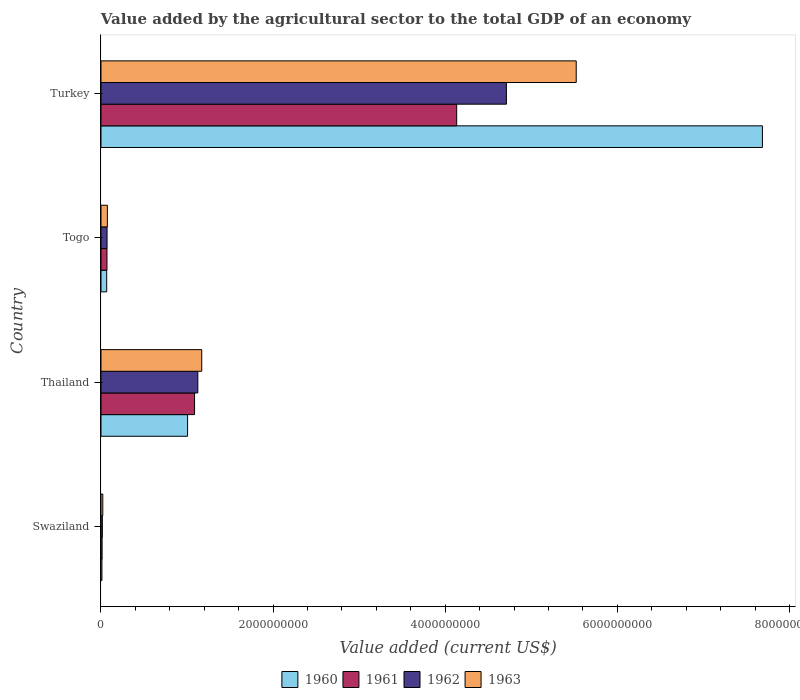How many groups of bars are there?
Ensure brevity in your answer.  4. Are the number of bars on each tick of the Y-axis equal?
Offer a terse response. Yes. How many bars are there on the 1st tick from the bottom?
Provide a succinct answer. 4. What is the label of the 2nd group of bars from the top?
Make the answer very short. Togo. In how many cases, is the number of bars for a given country not equal to the number of legend labels?
Provide a succinct answer. 0. What is the value added by the agricultural sector to the total GDP in 1960 in Turkey?
Your response must be concise. 7.69e+09. Across all countries, what is the maximum value added by the agricultural sector to the total GDP in 1961?
Offer a very short reply. 4.13e+09. Across all countries, what is the minimum value added by the agricultural sector to the total GDP in 1961?
Provide a succinct answer. 1.30e+07. In which country was the value added by the agricultural sector to the total GDP in 1961 maximum?
Your answer should be compact. Turkey. In which country was the value added by the agricultural sector to the total GDP in 1963 minimum?
Ensure brevity in your answer.  Swaziland. What is the total value added by the agricultural sector to the total GDP in 1962 in the graph?
Give a very brief answer. 5.92e+09. What is the difference between the value added by the agricultural sector to the total GDP in 1960 in Thailand and that in Turkey?
Your response must be concise. -6.68e+09. What is the difference between the value added by the agricultural sector to the total GDP in 1961 in Turkey and the value added by the agricultural sector to the total GDP in 1960 in Thailand?
Ensure brevity in your answer.  3.13e+09. What is the average value added by the agricultural sector to the total GDP in 1961 per country?
Offer a very short reply. 1.33e+09. What is the difference between the value added by the agricultural sector to the total GDP in 1962 and value added by the agricultural sector to the total GDP in 1963 in Swaziland?
Provide a short and direct response. -5.04e+06. What is the ratio of the value added by the agricultural sector to the total GDP in 1960 in Swaziland to that in Togo?
Ensure brevity in your answer.  0.17. What is the difference between the highest and the second highest value added by the agricultural sector to the total GDP in 1962?
Your response must be concise. 3.59e+09. What is the difference between the highest and the lowest value added by the agricultural sector to the total GDP in 1963?
Your answer should be compact. 5.50e+09. In how many countries, is the value added by the agricultural sector to the total GDP in 1962 greater than the average value added by the agricultural sector to the total GDP in 1962 taken over all countries?
Ensure brevity in your answer.  1. Is the sum of the value added by the agricultural sector to the total GDP in 1960 in Thailand and Togo greater than the maximum value added by the agricultural sector to the total GDP in 1961 across all countries?
Offer a terse response. No. What does the 3rd bar from the top in Togo represents?
Make the answer very short. 1961. Are all the bars in the graph horizontal?
Give a very brief answer. Yes. What is the difference between two consecutive major ticks on the X-axis?
Give a very brief answer. 2.00e+09. How are the legend labels stacked?
Provide a succinct answer. Horizontal. What is the title of the graph?
Provide a succinct answer. Value added by the agricultural sector to the total GDP of an economy. Does "2004" appear as one of the legend labels in the graph?
Provide a short and direct response. No. What is the label or title of the X-axis?
Provide a short and direct response. Value added (current US$). What is the Value added (current US$) in 1960 in Swaziland?
Ensure brevity in your answer.  1.11e+07. What is the Value added (current US$) in 1961 in Swaziland?
Your response must be concise. 1.30e+07. What is the Value added (current US$) of 1962 in Swaziland?
Keep it short and to the point. 1.60e+07. What is the Value added (current US$) of 1963 in Swaziland?
Provide a succinct answer. 2.10e+07. What is the Value added (current US$) of 1960 in Thailand?
Offer a very short reply. 1.01e+09. What is the Value added (current US$) in 1961 in Thailand?
Offer a very short reply. 1.09e+09. What is the Value added (current US$) of 1962 in Thailand?
Keep it short and to the point. 1.13e+09. What is the Value added (current US$) of 1963 in Thailand?
Offer a terse response. 1.17e+09. What is the Value added (current US$) of 1960 in Togo?
Keep it short and to the point. 6.65e+07. What is the Value added (current US$) in 1961 in Togo?
Offer a very short reply. 6.97e+07. What is the Value added (current US$) of 1962 in Togo?
Ensure brevity in your answer.  7.06e+07. What is the Value added (current US$) of 1963 in Togo?
Give a very brief answer. 7.43e+07. What is the Value added (current US$) of 1960 in Turkey?
Make the answer very short. 7.69e+09. What is the Value added (current US$) of 1961 in Turkey?
Your response must be concise. 4.13e+09. What is the Value added (current US$) of 1962 in Turkey?
Offer a very short reply. 4.71e+09. What is the Value added (current US$) in 1963 in Turkey?
Offer a very short reply. 5.52e+09. Across all countries, what is the maximum Value added (current US$) in 1960?
Offer a very short reply. 7.69e+09. Across all countries, what is the maximum Value added (current US$) of 1961?
Offer a terse response. 4.13e+09. Across all countries, what is the maximum Value added (current US$) in 1962?
Keep it short and to the point. 4.71e+09. Across all countries, what is the maximum Value added (current US$) of 1963?
Your answer should be compact. 5.52e+09. Across all countries, what is the minimum Value added (current US$) in 1960?
Your answer should be compact. 1.11e+07. Across all countries, what is the minimum Value added (current US$) in 1961?
Keep it short and to the point. 1.30e+07. Across all countries, what is the minimum Value added (current US$) in 1962?
Your response must be concise. 1.60e+07. Across all countries, what is the minimum Value added (current US$) in 1963?
Your answer should be compact. 2.10e+07. What is the total Value added (current US$) in 1960 in the graph?
Offer a very short reply. 8.77e+09. What is the total Value added (current US$) of 1961 in the graph?
Your response must be concise. 5.30e+09. What is the total Value added (current US$) of 1962 in the graph?
Provide a short and direct response. 5.92e+09. What is the total Value added (current US$) in 1963 in the graph?
Ensure brevity in your answer.  6.79e+09. What is the difference between the Value added (current US$) of 1960 in Swaziland and that in Thailand?
Make the answer very short. -9.95e+08. What is the difference between the Value added (current US$) of 1961 in Swaziland and that in Thailand?
Offer a very short reply. -1.07e+09. What is the difference between the Value added (current US$) in 1962 in Swaziland and that in Thailand?
Your answer should be compact. -1.11e+09. What is the difference between the Value added (current US$) in 1963 in Swaziland and that in Thailand?
Provide a short and direct response. -1.15e+09. What is the difference between the Value added (current US$) in 1960 in Swaziland and that in Togo?
Your answer should be compact. -5.54e+07. What is the difference between the Value added (current US$) of 1961 in Swaziland and that in Togo?
Offer a very short reply. -5.67e+07. What is the difference between the Value added (current US$) of 1962 in Swaziland and that in Togo?
Your response must be concise. -5.46e+07. What is the difference between the Value added (current US$) in 1963 in Swaziland and that in Togo?
Make the answer very short. -5.33e+07. What is the difference between the Value added (current US$) in 1960 in Swaziland and that in Turkey?
Provide a succinct answer. -7.67e+09. What is the difference between the Value added (current US$) in 1961 in Swaziland and that in Turkey?
Ensure brevity in your answer.  -4.12e+09. What is the difference between the Value added (current US$) in 1962 in Swaziland and that in Turkey?
Your response must be concise. -4.70e+09. What is the difference between the Value added (current US$) of 1963 in Swaziland and that in Turkey?
Your answer should be very brief. -5.50e+09. What is the difference between the Value added (current US$) in 1960 in Thailand and that in Togo?
Provide a succinct answer. 9.40e+08. What is the difference between the Value added (current US$) of 1961 in Thailand and that in Togo?
Your response must be concise. 1.02e+09. What is the difference between the Value added (current US$) of 1962 in Thailand and that in Togo?
Your answer should be very brief. 1.05e+09. What is the difference between the Value added (current US$) in 1963 in Thailand and that in Togo?
Provide a succinct answer. 1.10e+09. What is the difference between the Value added (current US$) of 1960 in Thailand and that in Turkey?
Provide a short and direct response. -6.68e+09. What is the difference between the Value added (current US$) in 1961 in Thailand and that in Turkey?
Provide a succinct answer. -3.05e+09. What is the difference between the Value added (current US$) in 1962 in Thailand and that in Turkey?
Give a very brief answer. -3.59e+09. What is the difference between the Value added (current US$) in 1963 in Thailand and that in Turkey?
Your response must be concise. -4.35e+09. What is the difference between the Value added (current US$) of 1960 in Togo and that in Turkey?
Offer a terse response. -7.62e+09. What is the difference between the Value added (current US$) in 1961 in Togo and that in Turkey?
Keep it short and to the point. -4.06e+09. What is the difference between the Value added (current US$) in 1962 in Togo and that in Turkey?
Offer a very short reply. -4.64e+09. What is the difference between the Value added (current US$) in 1963 in Togo and that in Turkey?
Give a very brief answer. -5.45e+09. What is the difference between the Value added (current US$) in 1960 in Swaziland and the Value added (current US$) in 1961 in Thailand?
Ensure brevity in your answer.  -1.08e+09. What is the difference between the Value added (current US$) in 1960 in Swaziland and the Value added (current US$) in 1962 in Thailand?
Make the answer very short. -1.11e+09. What is the difference between the Value added (current US$) in 1960 in Swaziland and the Value added (current US$) in 1963 in Thailand?
Your answer should be compact. -1.16e+09. What is the difference between the Value added (current US$) of 1961 in Swaziland and the Value added (current US$) of 1962 in Thailand?
Offer a very short reply. -1.11e+09. What is the difference between the Value added (current US$) in 1961 in Swaziland and the Value added (current US$) in 1963 in Thailand?
Your answer should be very brief. -1.16e+09. What is the difference between the Value added (current US$) of 1962 in Swaziland and the Value added (current US$) of 1963 in Thailand?
Your response must be concise. -1.15e+09. What is the difference between the Value added (current US$) of 1960 in Swaziland and the Value added (current US$) of 1961 in Togo?
Ensure brevity in your answer.  -5.87e+07. What is the difference between the Value added (current US$) in 1960 in Swaziland and the Value added (current US$) in 1962 in Togo?
Offer a very short reply. -5.95e+07. What is the difference between the Value added (current US$) of 1960 in Swaziland and the Value added (current US$) of 1963 in Togo?
Make the answer very short. -6.32e+07. What is the difference between the Value added (current US$) of 1961 in Swaziland and the Value added (current US$) of 1962 in Togo?
Ensure brevity in your answer.  -5.76e+07. What is the difference between the Value added (current US$) in 1961 in Swaziland and the Value added (current US$) in 1963 in Togo?
Your answer should be very brief. -6.13e+07. What is the difference between the Value added (current US$) of 1962 in Swaziland and the Value added (current US$) of 1963 in Togo?
Offer a terse response. -5.83e+07. What is the difference between the Value added (current US$) of 1960 in Swaziland and the Value added (current US$) of 1961 in Turkey?
Offer a very short reply. -4.12e+09. What is the difference between the Value added (current US$) of 1960 in Swaziland and the Value added (current US$) of 1962 in Turkey?
Your answer should be very brief. -4.70e+09. What is the difference between the Value added (current US$) in 1960 in Swaziland and the Value added (current US$) in 1963 in Turkey?
Give a very brief answer. -5.51e+09. What is the difference between the Value added (current US$) of 1961 in Swaziland and the Value added (current US$) of 1962 in Turkey?
Keep it short and to the point. -4.70e+09. What is the difference between the Value added (current US$) in 1961 in Swaziland and the Value added (current US$) in 1963 in Turkey?
Give a very brief answer. -5.51e+09. What is the difference between the Value added (current US$) in 1962 in Swaziland and the Value added (current US$) in 1963 in Turkey?
Your response must be concise. -5.51e+09. What is the difference between the Value added (current US$) of 1960 in Thailand and the Value added (current US$) of 1961 in Togo?
Your answer should be compact. 9.36e+08. What is the difference between the Value added (current US$) of 1960 in Thailand and the Value added (current US$) of 1962 in Togo?
Make the answer very short. 9.36e+08. What is the difference between the Value added (current US$) in 1960 in Thailand and the Value added (current US$) in 1963 in Togo?
Provide a succinct answer. 9.32e+08. What is the difference between the Value added (current US$) of 1961 in Thailand and the Value added (current US$) of 1962 in Togo?
Offer a terse response. 1.02e+09. What is the difference between the Value added (current US$) of 1961 in Thailand and the Value added (current US$) of 1963 in Togo?
Make the answer very short. 1.01e+09. What is the difference between the Value added (current US$) in 1962 in Thailand and the Value added (current US$) in 1963 in Togo?
Keep it short and to the point. 1.05e+09. What is the difference between the Value added (current US$) in 1960 in Thailand and the Value added (current US$) in 1961 in Turkey?
Provide a succinct answer. -3.13e+09. What is the difference between the Value added (current US$) in 1960 in Thailand and the Value added (current US$) in 1962 in Turkey?
Your answer should be very brief. -3.70e+09. What is the difference between the Value added (current US$) in 1960 in Thailand and the Value added (current US$) in 1963 in Turkey?
Your response must be concise. -4.52e+09. What is the difference between the Value added (current US$) of 1961 in Thailand and the Value added (current US$) of 1962 in Turkey?
Ensure brevity in your answer.  -3.62e+09. What is the difference between the Value added (current US$) of 1961 in Thailand and the Value added (current US$) of 1963 in Turkey?
Keep it short and to the point. -4.43e+09. What is the difference between the Value added (current US$) in 1962 in Thailand and the Value added (current US$) in 1963 in Turkey?
Provide a short and direct response. -4.40e+09. What is the difference between the Value added (current US$) of 1960 in Togo and the Value added (current US$) of 1961 in Turkey?
Offer a very short reply. -4.07e+09. What is the difference between the Value added (current US$) of 1960 in Togo and the Value added (current US$) of 1962 in Turkey?
Your answer should be compact. -4.64e+09. What is the difference between the Value added (current US$) in 1960 in Togo and the Value added (current US$) in 1963 in Turkey?
Keep it short and to the point. -5.46e+09. What is the difference between the Value added (current US$) of 1961 in Togo and the Value added (current US$) of 1962 in Turkey?
Give a very brief answer. -4.64e+09. What is the difference between the Value added (current US$) of 1961 in Togo and the Value added (current US$) of 1963 in Turkey?
Keep it short and to the point. -5.45e+09. What is the difference between the Value added (current US$) of 1962 in Togo and the Value added (current US$) of 1963 in Turkey?
Provide a short and direct response. -5.45e+09. What is the average Value added (current US$) in 1960 per country?
Offer a very short reply. 2.19e+09. What is the average Value added (current US$) in 1961 per country?
Make the answer very short. 1.33e+09. What is the average Value added (current US$) of 1962 per country?
Your answer should be compact. 1.48e+09. What is the average Value added (current US$) in 1963 per country?
Provide a succinct answer. 1.70e+09. What is the difference between the Value added (current US$) of 1960 and Value added (current US$) of 1961 in Swaziland?
Give a very brief answer. -1.96e+06. What is the difference between the Value added (current US$) of 1960 and Value added (current US$) of 1962 in Swaziland?
Your answer should be very brief. -4.90e+06. What is the difference between the Value added (current US$) in 1960 and Value added (current US$) in 1963 in Swaziland?
Offer a very short reply. -9.94e+06. What is the difference between the Value added (current US$) in 1961 and Value added (current US$) in 1962 in Swaziland?
Offer a very short reply. -2.94e+06. What is the difference between the Value added (current US$) in 1961 and Value added (current US$) in 1963 in Swaziland?
Provide a succinct answer. -7.98e+06. What is the difference between the Value added (current US$) in 1962 and Value added (current US$) in 1963 in Swaziland?
Provide a succinct answer. -5.04e+06. What is the difference between the Value added (current US$) in 1960 and Value added (current US$) in 1961 in Thailand?
Offer a very short reply. -8.12e+07. What is the difference between the Value added (current US$) in 1960 and Value added (current US$) in 1962 in Thailand?
Ensure brevity in your answer.  -1.19e+08. What is the difference between the Value added (current US$) of 1960 and Value added (current US$) of 1963 in Thailand?
Keep it short and to the point. -1.65e+08. What is the difference between the Value added (current US$) in 1961 and Value added (current US$) in 1962 in Thailand?
Give a very brief answer. -3.78e+07. What is the difference between the Value added (current US$) in 1961 and Value added (current US$) in 1963 in Thailand?
Provide a succinct answer. -8.33e+07. What is the difference between the Value added (current US$) in 1962 and Value added (current US$) in 1963 in Thailand?
Your answer should be compact. -4.55e+07. What is the difference between the Value added (current US$) of 1960 and Value added (current US$) of 1961 in Togo?
Offer a terse response. -3.24e+06. What is the difference between the Value added (current US$) in 1960 and Value added (current US$) in 1962 in Togo?
Ensure brevity in your answer.  -4.13e+06. What is the difference between the Value added (current US$) of 1960 and Value added (current US$) of 1963 in Togo?
Offer a very short reply. -7.80e+06. What is the difference between the Value added (current US$) in 1961 and Value added (current US$) in 1962 in Togo?
Provide a short and direct response. -8.86e+05. What is the difference between the Value added (current US$) in 1961 and Value added (current US$) in 1963 in Togo?
Provide a short and direct response. -4.56e+06. What is the difference between the Value added (current US$) of 1962 and Value added (current US$) of 1963 in Togo?
Keep it short and to the point. -3.67e+06. What is the difference between the Value added (current US$) of 1960 and Value added (current US$) of 1961 in Turkey?
Give a very brief answer. 3.55e+09. What is the difference between the Value added (current US$) in 1960 and Value added (current US$) in 1962 in Turkey?
Offer a terse response. 2.97e+09. What is the difference between the Value added (current US$) in 1960 and Value added (current US$) in 1963 in Turkey?
Provide a short and direct response. 2.16e+09. What is the difference between the Value added (current US$) of 1961 and Value added (current US$) of 1962 in Turkey?
Ensure brevity in your answer.  -5.78e+08. What is the difference between the Value added (current US$) in 1961 and Value added (current US$) in 1963 in Turkey?
Offer a very short reply. -1.39e+09. What is the difference between the Value added (current US$) of 1962 and Value added (current US$) of 1963 in Turkey?
Give a very brief answer. -8.11e+08. What is the ratio of the Value added (current US$) of 1960 in Swaziland to that in Thailand?
Your answer should be very brief. 0.01. What is the ratio of the Value added (current US$) in 1961 in Swaziland to that in Thailand?
Offer a very short reply. 0.01. What is the ratio of the Value added (current US$) of 1962 in Swaziland to that in Thailand?
Ensure brevity in your answer.  0.01. What is the ratio of the Value added (current US$) of 1963 in Swaziland to that in Thailand?
Give a very brief answer. 0.02. What is the ratio of the Value added (current US$) in 1960 in Swaziland to that in Togo?
Ensure brevity in your answer.  0.17. What is the ratio of the Value added (current US$) of 1961 in Swaziland to that in Togo?
Provide a succinct answer. 0.19. What is the ratio of the Value added (current US$) of 1962 in Swaziland to that in Togo?
Provide a short and direct response. 0.23. What is the ratio of the Value added (current US$) of 1963 in Swaziland to that in Togo?
Make the answer very short. 0.28. What is the ratio of the Value added (current US$) in 1960 in Swaziland to that in Turkey?
Ensure brevity in your answer.  0. What is the ratio of the Value added (current US$) in 1961 in Swaziland to that in Turkey?
Ensure brevity in your answer.  0. What is the ratio of the Value added (current US$) of 1962 in Swaziland to that in Turkey?
Ensure brevity in your answer.  0. What is the ratio of the Value added (current US$) of 1963 in Swaziland to that in Turkey?
Your answer should be compact. 0. What is the ratio of the Value added (current US$) of 1960 in Thailand to that in Togo?
Your answer should be compact. 15.13. What is the ratio of the Value added (current US$) in 1961 in Thailand to that in Togo?
Ensure brevity in your answer.  15.6. What is the ratio of the Value added (current US$) of 1962 in Thailand to that in Togo?
Offer a terse response. 15.93. What is the ratio of the Value added (current US$) in 1963 in Thailand to that in Togo?
Keep it short and to the point. 15.76. What is the ratio of the Value added (current US$) in 1960 in Thailand to that in Turkey?
Your response must be concise. 0.13. What is the ratio of the Value added (current US$) of 1961 in Thailand to that in Turkey?
Give a very brief answer. 0.26. What is the ratio of the Value added (current US$) in 1962 in Thailand to that in Turkey?
Provide a succinct answer. 0.24. What is the ratio of the Value added (current US$) in 1963 in Thailand to that in Turkey?
Provide a succinct answer. 0.21. What is the ratio of the Value added (current US$) in 1960 in Togo to that in Turkey?
Offer a very short reply. 0.01. What is the ratio of the Value added (current US$) of 1961 in Togo to that in Turkey?
Offer a very short reply. 0.02. What is the ratio of the Value added (current US$) in 1962 in Togo to that in Turkey?
Your answer should be compact. 0.01. What is the ratio of the Value added (current US$) in 1963 in Togo to that in Turkey?
Ensure brevity in your answer.  0.01. What is the difference between the highest and the second highest Value added (current US$) of 1960?
Give a very brief answer. 6.68e+09. What is the difference between the highest and the second highest Value added (current US$) of 1961?
Keep it short and to the point. 3.05e+09. What is the difference between the highest and the second highest Value added (current US$) of 1962?
Your answer should be compact. 3.59e+09. What is the difference between the highest and the second highest Value added (current US$) of 1963?
Ensure brevity in your answer.  4.35e+09. What is the difference between the highest and the lowest Value added (current US$) in 1960?
Offer a very short reply. 7.67e+09. What is the difference between the highest and the lowest Value added (current US$) of 1961?
Provide a short and direct response. 4.12e+09. What is the difference between the highest and the lowest Value added (current US$) of 1962?
Your response must be concise. 4.70e+09. What is the difference between the highest and the lowest Value added (current US$) of 1963?
Ensure brevity in your answer.  5.50e+09. 